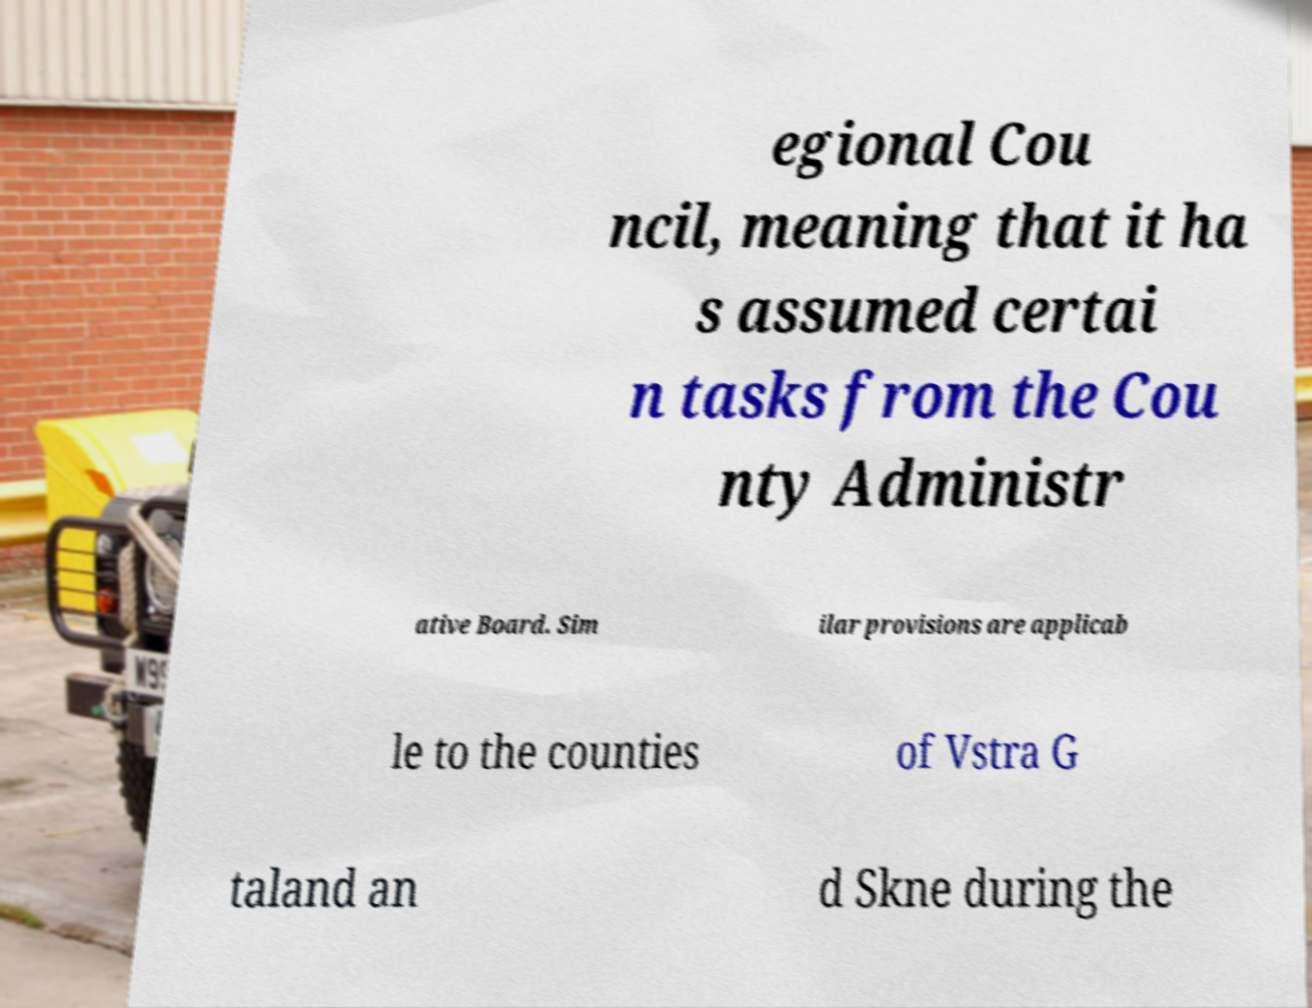What messages or text are displayed in this image? I need them in a readable, typed format. egional Cou ncil, meaning that it ha s assumed certai n tasks from the Cou nty Administr ative Board. Sim ilar provisions are applicab le to the counties of Vstra G taland an d Skne during the 